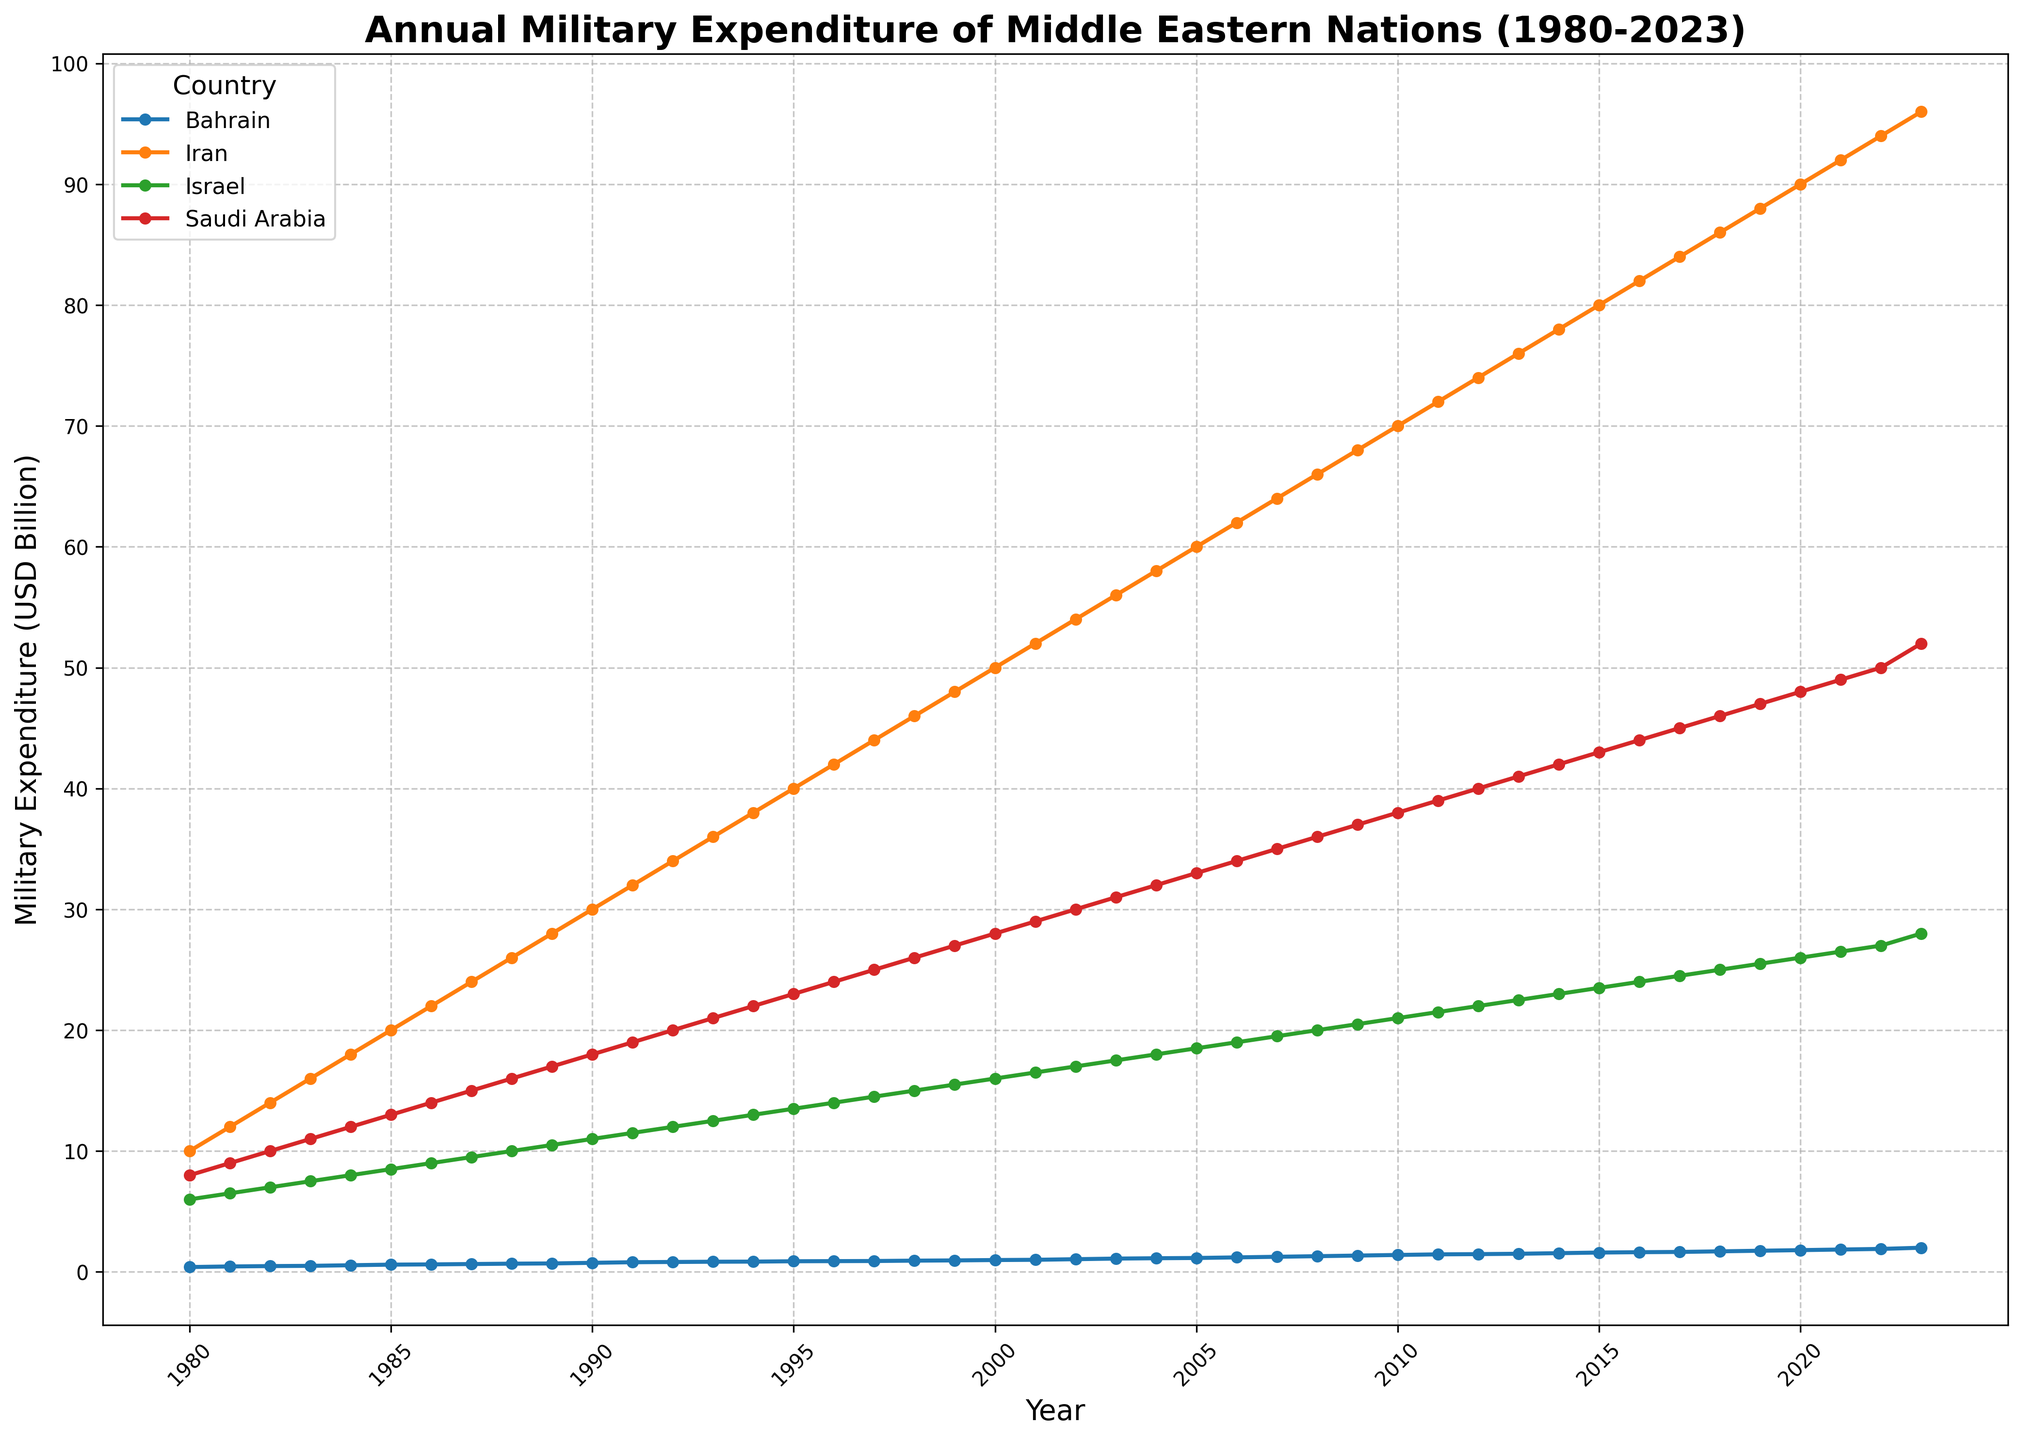What's the trend of Bahrain's military expenditure from 1980 to 2023? Bahrain's military expenditure shows a general increasing trend from 1980 to 2023. Initially starting at 0.4 billion USD in 1980, it gradually increases to reach 2.0 billion USD in 2023.
Answer: Increasing Between the years 2000 and 2023, which country shows the highest absolute increase in military expenditure? Iran shows the highest absolute increase between 2000 and 2023. In 2000, Iran's expenditure is 50 billion USD and it increases to 96 billion USD in 2023, which is an increase of 46 billion USD.
Answer: Iran Which country had the lowest military expenditure in 2023? In 2023, Bahrain had the lowest military expenditure among the considered Middle Eastern countries, at 2 billion USD.
Answer: Bahrain How does Israel's military expenditure in 1980 compare to its expenditure in 2023? Israel's military expenditure in 1980 was 6 billion USD, and by 2023, it increased to 28 billion USD. This represents a total increase of 22 billion USD over the period.
Answer: 22 billion USD increase What visual patterns can you observe among the countries' military expenditures in terms of growth over time? Visually, all countries show a consistent upward trend in military expenditure from 1980 to 2023. Iran and Saudi Arabia exhibit substantial growth compared to the others, while Bahrain has the least expenditure.
Answer: Consistent upward trend Compare the military expenditures of Saudi Arabia and Israel in 1985. Which country spent more and by how much? In 1985, Saudi Arabia spent 13 billion USD on military expenditures, while Israel spent 8.5 billion USD. Therefore, Saudi Arabia spent 4.5 billion USD more than Israel in 1985.
Answer: Saudi Arabia, 4.5 billion USD more Calculate the average annual military expenditure of Iran from 1980 to 1990. The military expenditures of Iran from 1980 to 1990 are: [10, 12, 14, 16, 18, 20, 22, 24, 26, 28]. Summing these values gives 190 billion USD. Dividing by 11 years, the average annual expenditure is approximately 19.09 billion USD.
Answer: ~19.09 billion USD Between Israel and Bahrain, which country shows a higher rate of increase in military expenditure from 1990 to 2000? Israel’s military expenditure increases from 11 billion USD in 1990 to 16 billion USD in 2000 (5 billion USD increase). Bahrain’s military expenditure increases from 0.75 billion USD in 1990 to 0.98 billion USD in 2000 (0.23 billion USD increase). Israel shows a higher absolute increase.
Answer: Israel 